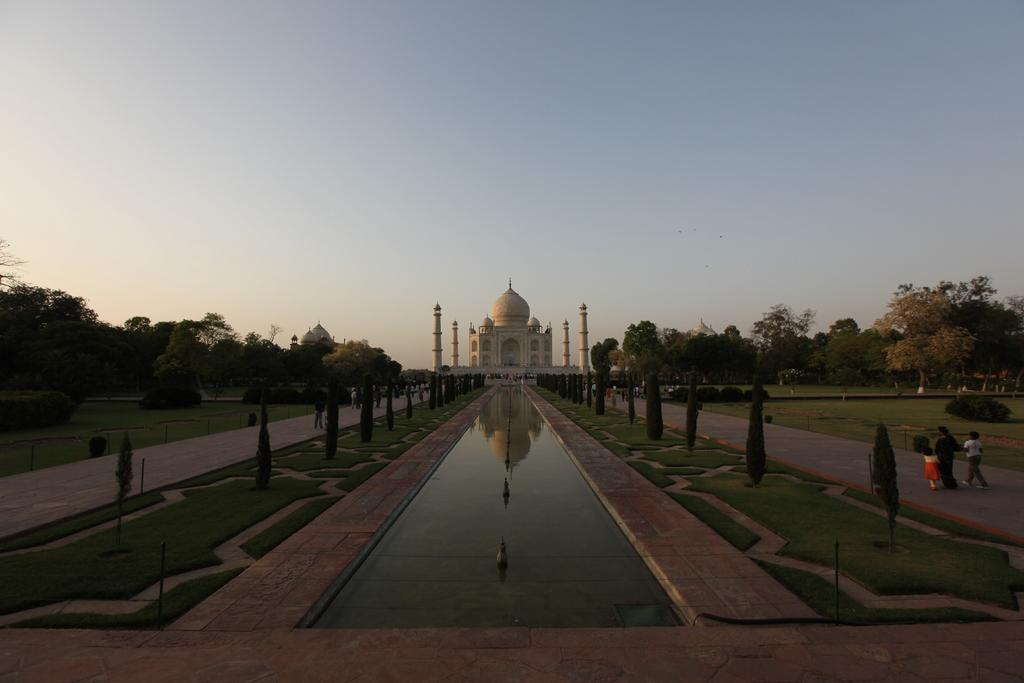What type of structure is present in the image? There is a historical monument in the image. What type of natural elements can be seen in the image? There are trees and water visible in the image. Are there any living beings in the image? Yes, there are people in the image. What other types of vegetation can be seen in the image? There are bushes in the image. What is visible at the top of the image? The sky is visible at the top of the image. What type of dress is the farmer wearing in the image? There is no farmer present in the image, and therefore no dress to describe. 